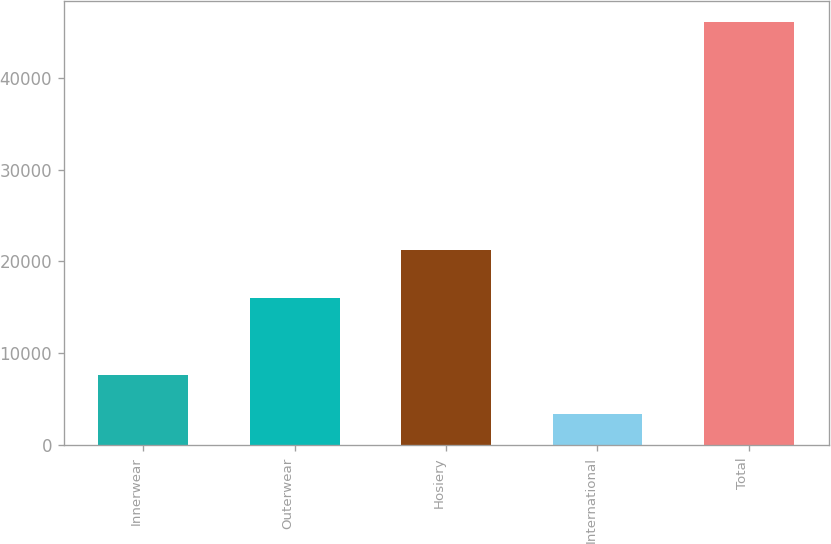Convert chart to OTSL. <chart><loc_0><loc_0><loc_500><loc_500><bar_chart><fcel>Innerwear<fcel>Outerwear<fcel>Hosiery<fcel>International<fcel>Total<nl><fcel>7671.7<fcel>16062<fcel>21302<fcel>3406<fcel>46063<nl></chart> 